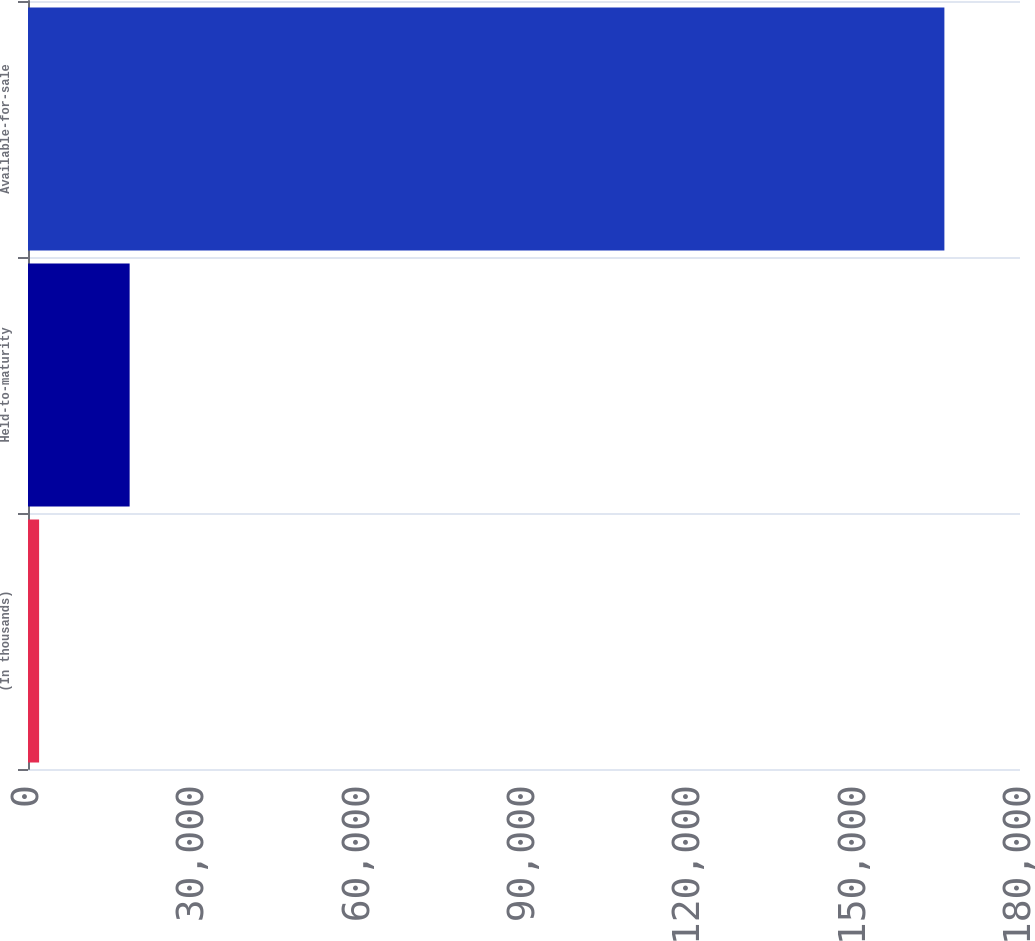<chart> <loc_0><loc_0><loc_500><loc_500><bar_chart><fcel>(In thousands)<fcel>Held-to-maturity<fcel>Available-for-sale<nl><fcel>2016<fcel>18442.5<fcel>166281<nl></chart> 